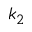Convert formula to latex. <formula><loc_0><loc_0><loc_500><loc_500>k _ { 2 }</formula> 